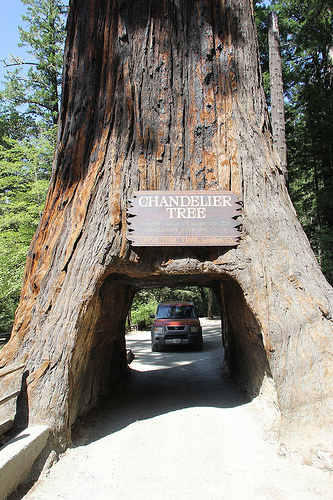<image>
Is the sign on the tree? Yes. Looking at the image, I can see the sign is positioned on top of the tree, with the tree providing support. Is the car under the tree? No. The car is not positioned under the tree. The vertical relationship between these objects is different. Is there a car behind the tree? Yes. From this viewpoint, the car is positioned behind the tree, with the tree partially or fully occluding the car. Is the tree in front of the car? Yes. The tree is positioned in front of the car, appearing closer to the camera viewpoint. 